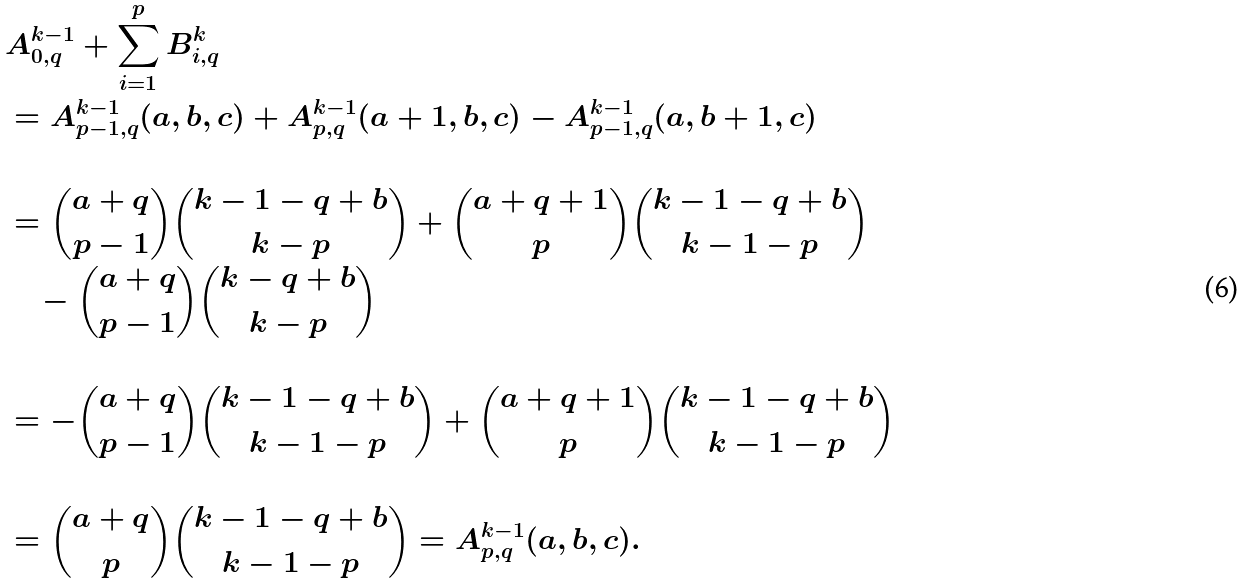Convert formula to latex. <formula><loc_0><loc_0><loc_500><loc_500>& A _ { 0 , q } ^ { k - 1 } + \sum _ { i = 1 } ^ { p } B _ { i , q } ^ { k } \\ & = A _ { p - 1 , q } ^ { k - 1 } ( a , b , c ) + A ^ { k - 1 } _ { p , q } ( a + 1 , b , c ) - A _ { p - 1 , q } ^ { k - 1 } ( a , b + 1 , c ) \\ & \\ & = \binom { a + q } { p - 1 } \binom { k - 1 - q + b } { k - p } + \binom { a + q + 1 } { p } \binom { k - 1 - q + b } { k - 1 - p } \\ & \quad - \binom { a + q } { p - 1 } \binom { k - q + b } { k - p } \\ & \\ & = - \binom { a + q } { p - 1 } \binom { k - 1 - q + b } { k - 1 - p } + \binom { a + q + 1 } { p } \binom { k - 1 - q + b } { k - 1 - p } \\ & \\ & = \binom { a + q } { p } \binom { k - 1 - q + b } { k - 1 - p } = A _ { p , q } ^ { k - 1 } ( a , b , c ) .</formula> 